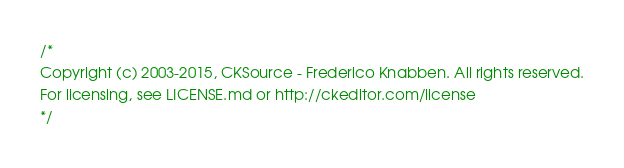<code> <loc_0><loc_0><loc_500><loc_500><_CSS_>/*
Copyright (c) 2003-2015, CKSource - Frederico Knabben. All rights reserved.
For licensing, see LICENSE.md or http://ckeditor.com/license
*/</code> 